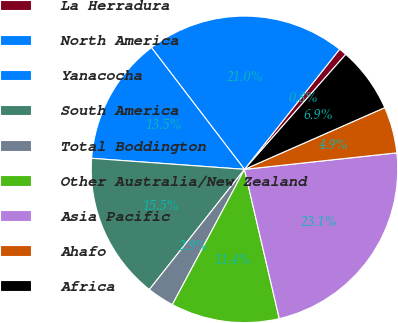<chart> <loc_0><loc_0><loc_500><loc_500><pie_chart><fcel>La Herradura<fcel>North America<fcel>Yanacocha<fcel>South America<fcel>Total Boddington<fcel>Other Australia/New Zealand<fcel>Asia Pacific<fcel>Ahafo<fcel>Africa<nl><fcel>0.83%<fcel>21.04%<fcel>13.47%<fcel>15.49%<fcel>2.86%<fcel>11.44%<fcel>23.07%<fcel>4.88%<fcel>6.91%<nl></chart> 